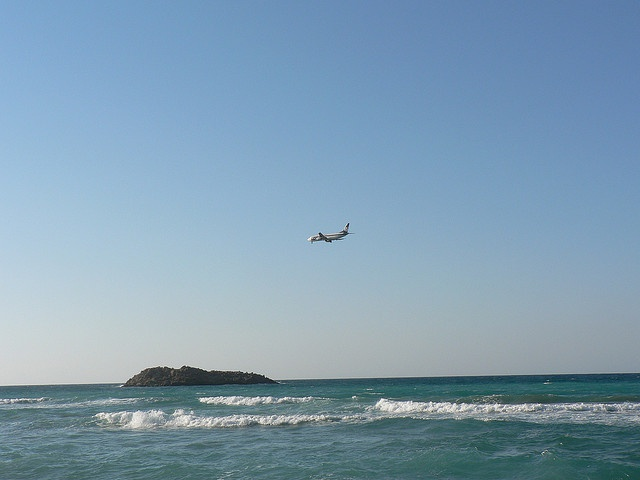Describe the objects in this image and their specific colors. I can see a airplane in lightblue, gray, darkgray, black, and lightgray tones in this image. 